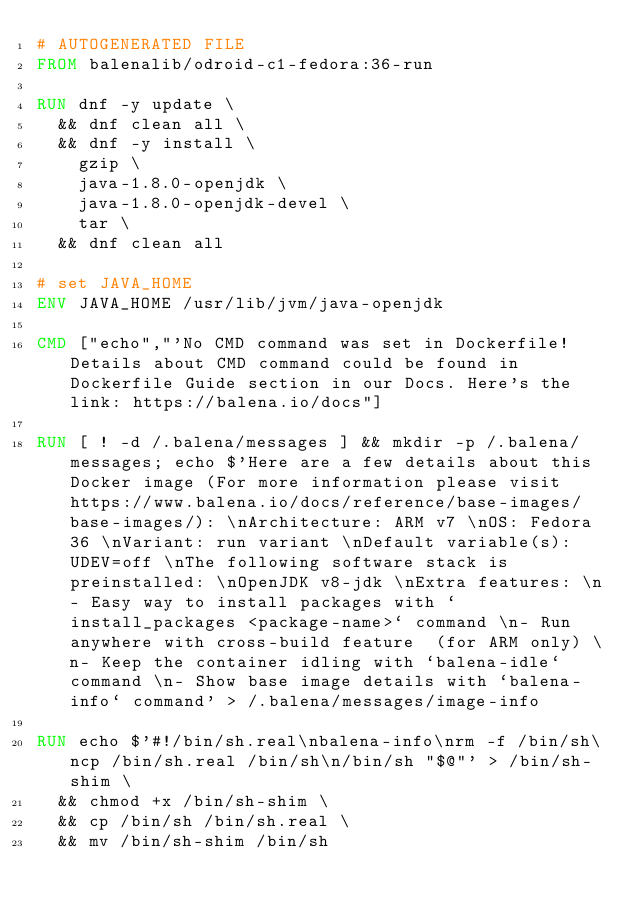Convert code to text. <code><loc_0><loc_0><loc_500><loc_500><_Dockerfile_># AUTOGENERATED FILE
FROM balenalib/odroid-c1-fedora:36-run

RUN dnf -y update \
	&& dnf clean all \
	&& dnf -y install \
		gzip \
		java-1.8.0-openjdk \
		java-1.8.0-openjdk-devel \
		tar \
	&& dnf clean all

# set JAVA_HOME
ENV JAVA_HOME /usr/lib/jvm/java-openjdk

CMD ["echo","'No CMD command was set in Dockerfile! Details about CMD command could be found in Dockerfile Guide section in our Docs. Here's the link: https://balena.io/docs"]

RUN [ ! -d /.balena/messages ] && mkdir -p /.balena/messages; echo $'Here are a few details about this Docker image (For more information please visit https://www.balena.io/docs/reference/base-images/base-images/): \nArchitecture: ARM v7 \nOS: Fedora 36 \nVariant: run variant \nDefault variable(s): UDEV=off \nThe following software stack is preinstalled: \nOpenJDK v8-jdk \nExtra features: \n- Easy way to install packages with `install_packages <package-name>` command \n- Run anywhere with cross-build feature  (for ARM only) \n- Keep the container idling with `balena-idle` command \n- Show base image details with `balena-info` command' > /.balena/messages/image-info

RUN echo $'#!/bin/sh.real\nbalena-info\nrm -f /bin/sh\ncp /bin/sh.real /bin/sh\n/bin/sh "$@"' > /bin/sh-shim \
	&& chmod +x /bin/sh-shim \
	&& cp /bin/sh /bin/sh.real \
	&& mv /bin/sh-shim /bin/sh</code> 